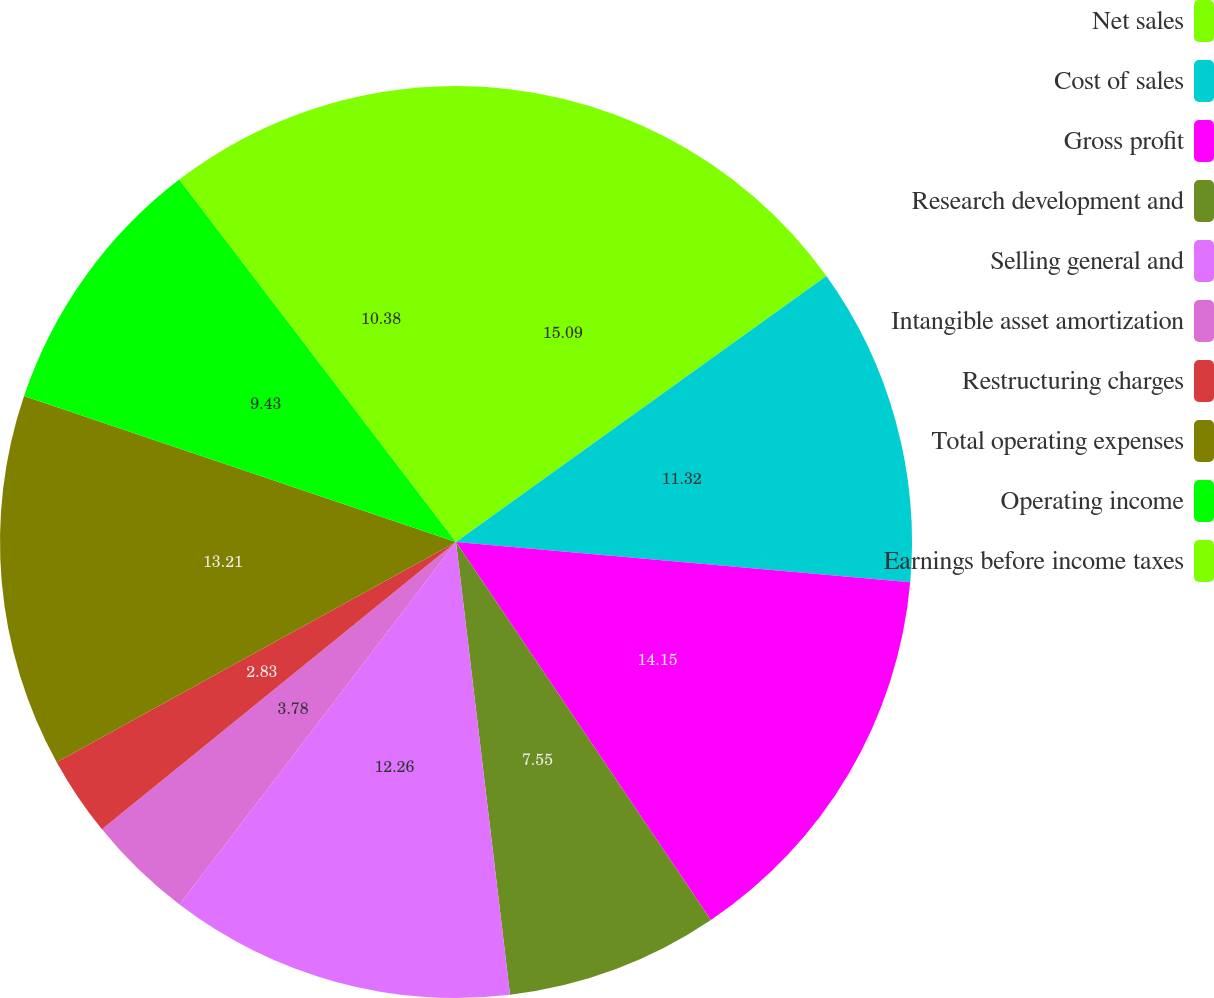Convert chart. <chart><loc_0><loc_0><loc_500><loc_500><pie_chart><fcel>Net sales<fcel>Cost of sales<fcel>Gross profit<fcel>Research development and<fcel>Selling general and<fcel>Intangible asset amortization<fcel>Restructuring charges<fcel>Total operating expenses<fcel>Operating income<fcel>Earnings before income taxes<nl><fcel>15.09%<fcel>11.32%<fcel>14.15%<fcel>7.55%<fcel>12.26%<fcel>3.78%<fcel>2.83%<fcel>13.21%<fcel>9.43%<fcel>10.38%<nl></chart> 